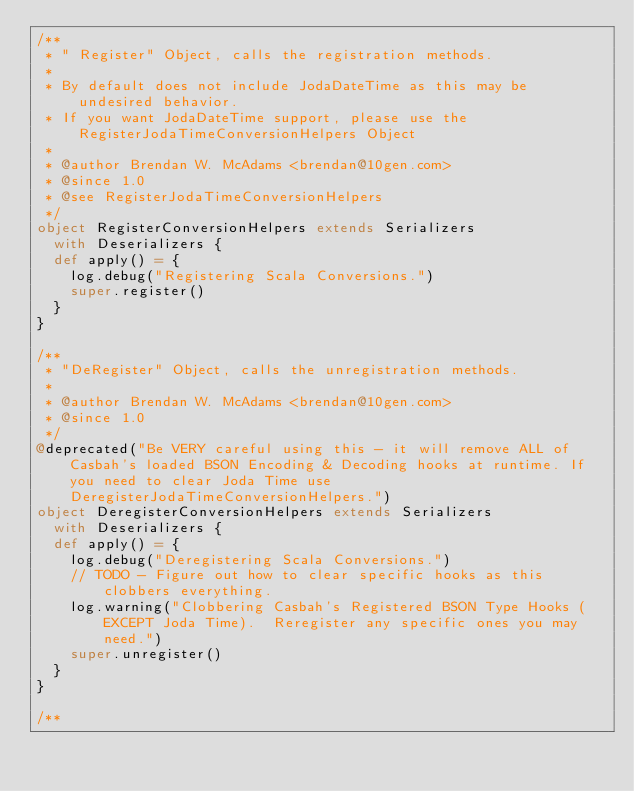<code> <loc_0><loc_0><loc_500><loc_500><_Scala_>/** 
 * " Register" Object, calls the registration methods.
 * 
 * By default does not include JodaDateTime as this may be undesired behavior.
 * If you want JodaDateTime support, please use the RegisterJodaTimeConversionHelpers Object
 * 
 * @author Brendan W. McAdams <brendan@10gen.com>
 * @since 1.0
 * @see RegisterJodaTimeConversionHelpers
 */
object RegisterConversionHelpers extends Serializers
  with Deserializers {
  def apply() = {
    log.debug("Registering Scala Conversions.")
    super.register()
  }
}

/** 
 * "DeRegister" Object, calls the unregistration methods.
 * 
 * @author Brendan W. McAdams <brendan@10gen.com>
 * @since 1.0
 */
@deprecated("Be VERY careful using this - it will remove ALL of Casbah's loaded BSON Encoding & Decoding hooks at runtime. If you need to clear Joda Time use DeregisterJodaTimeConversionHelpers.")
object DeregisterConversionHelpers extends Serializers
  with Deserializers {
  def apply() = {
    log.debug("Deregistering Scala Conversions.")
    // TODO - Figure out how to clear specific hooks as this clobbers everything.
    log.warning("Clobbering Casbah's Registered BSON Type Hooks (EXCEPT Joda Time).  Reregister any specific ones you may need.")
    super.unregister()
  }
}

/** </code> 